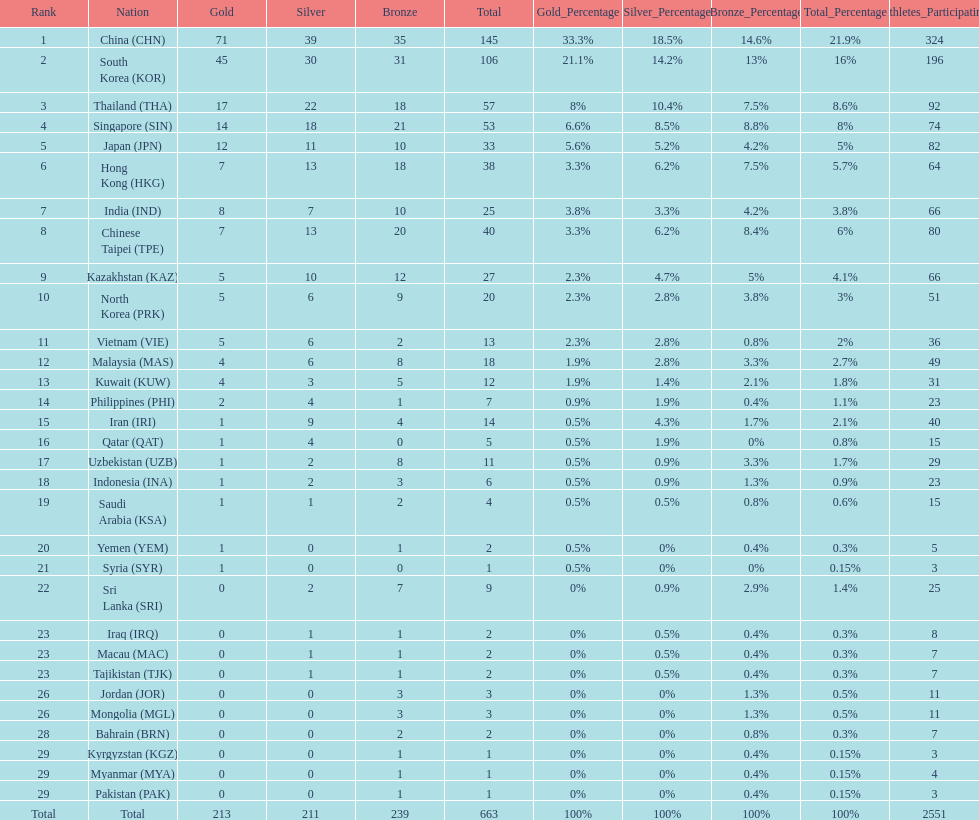How many countries have at least 10 gold medals in the asian youth games? 5. 